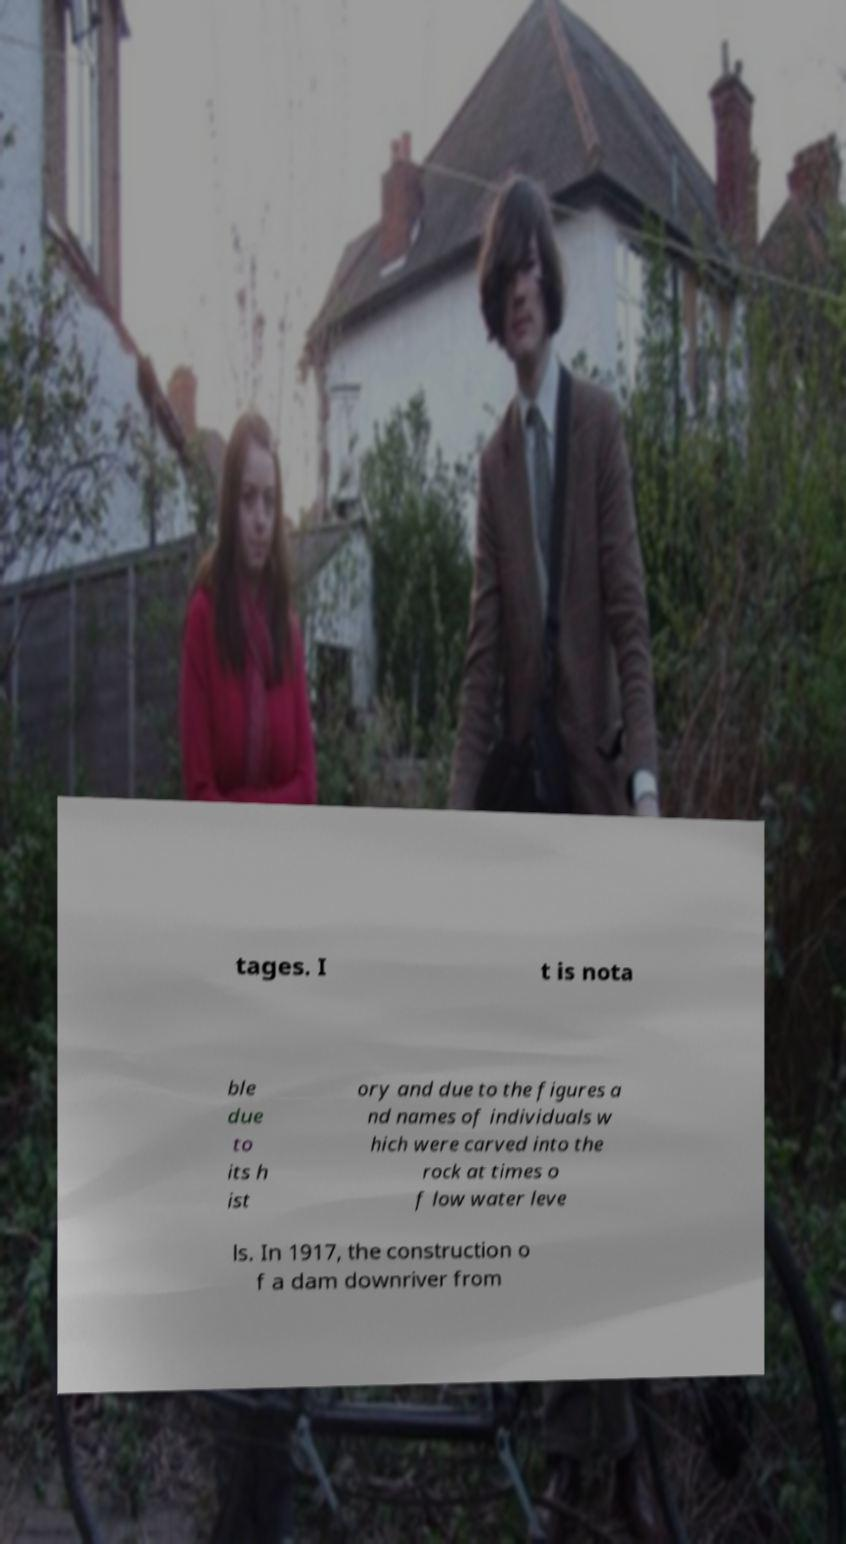Please read and relay the text visible in this image. What does it say? tages. I t is nota ble due to its h ist ory and due to the figures a nd names of individuals w hich were carved into the rock at times o f low water leve ls. In 1917, the construction o f a dam downriver from 